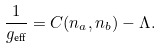<formula> <loc_0><loc_0><loc_500><loc_500>\frac { 1 } { g _ { \text {eff} } } = C ( n _ { a } , n _ { b } ) - \Lambda .</formula> 